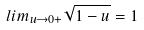Convert formula to latex. <formula><loc_0><loc_0><loc_500><loc_500>l i m _ { u \rightarrow 0 + } \sqrt { 1 - u } = 1</formula> 